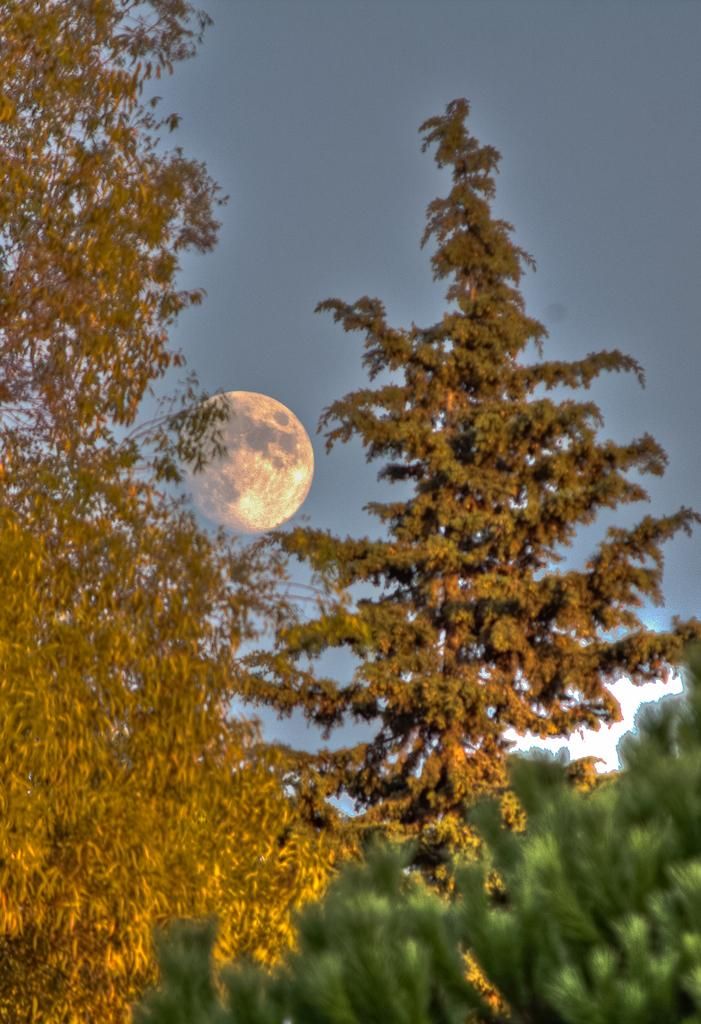Where was the picture taken? The picture was clicked outside the city. What can be seen in the center of the image? There are trees in the center of the image. What celestial body is visible in the sky? The moon is visible in the sky. What part of the natural environment is visible in the background of the image? The sky is visible in the background of the image. What type of sock is hanging from the tree in the image? There is no sock present in the image; it features trees and a visible moon in the sky. What type of produce can be seen growing on the trees in the image? There is no produce visible on the trees in the image; they are simply trees without any fruits or vegetables. 